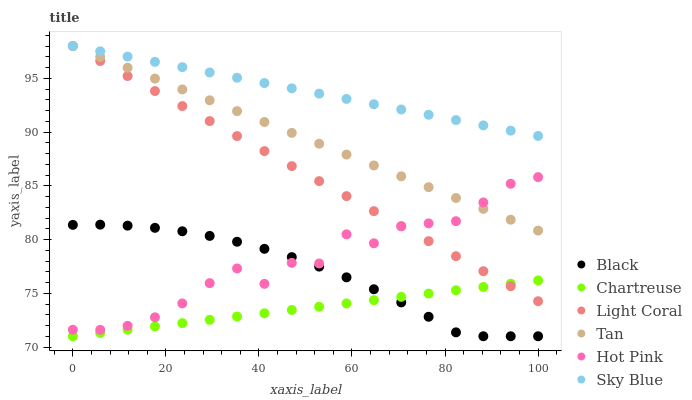Does Chartreuse have the minimum area under the curve?
Answer yes or no. Yes. Does Sky Blue have the maximum area under the curve?
Answer yes or no. Yes. Does Light Coral have the minimum area under the curve?
Answer yes or no. No. Does Light Coral have the maximum area under the curve?
Answer yes or no. No. Is Chartreuse the smoothest?
Answer yes or no. Yes. Is Hot Pink the roughest?
Answer yes or no. Yes. Is Light Coral the smoothest?
Answer yes or no. No. Is Light Coral the roughest?
Answer yes or no. No. Does Chartreuse have the lowest value?
Answer yes or no. Yes. Does Light Coral have the lowest value?
Answer yes or no. No. Does Tan have the highest value?
Answer yes or no. Yes. Does Chartreuse have the highest value?
Answer yes or no. No. Is Chartreuse less than Tan?
Answer yes or no. Yes. Is Tan greater than Chartreuse?
Answer yes or no. Yes. Does Hot Pink intersect Black?
Answer yes or no. Yes. Is Hot Pink less than Black?
Answer yes or no. No. Is Hot Pink greater than Black?
Answer yes or no. No. Does Chartreuse intersect Tan?
Answer yes or no. No. 